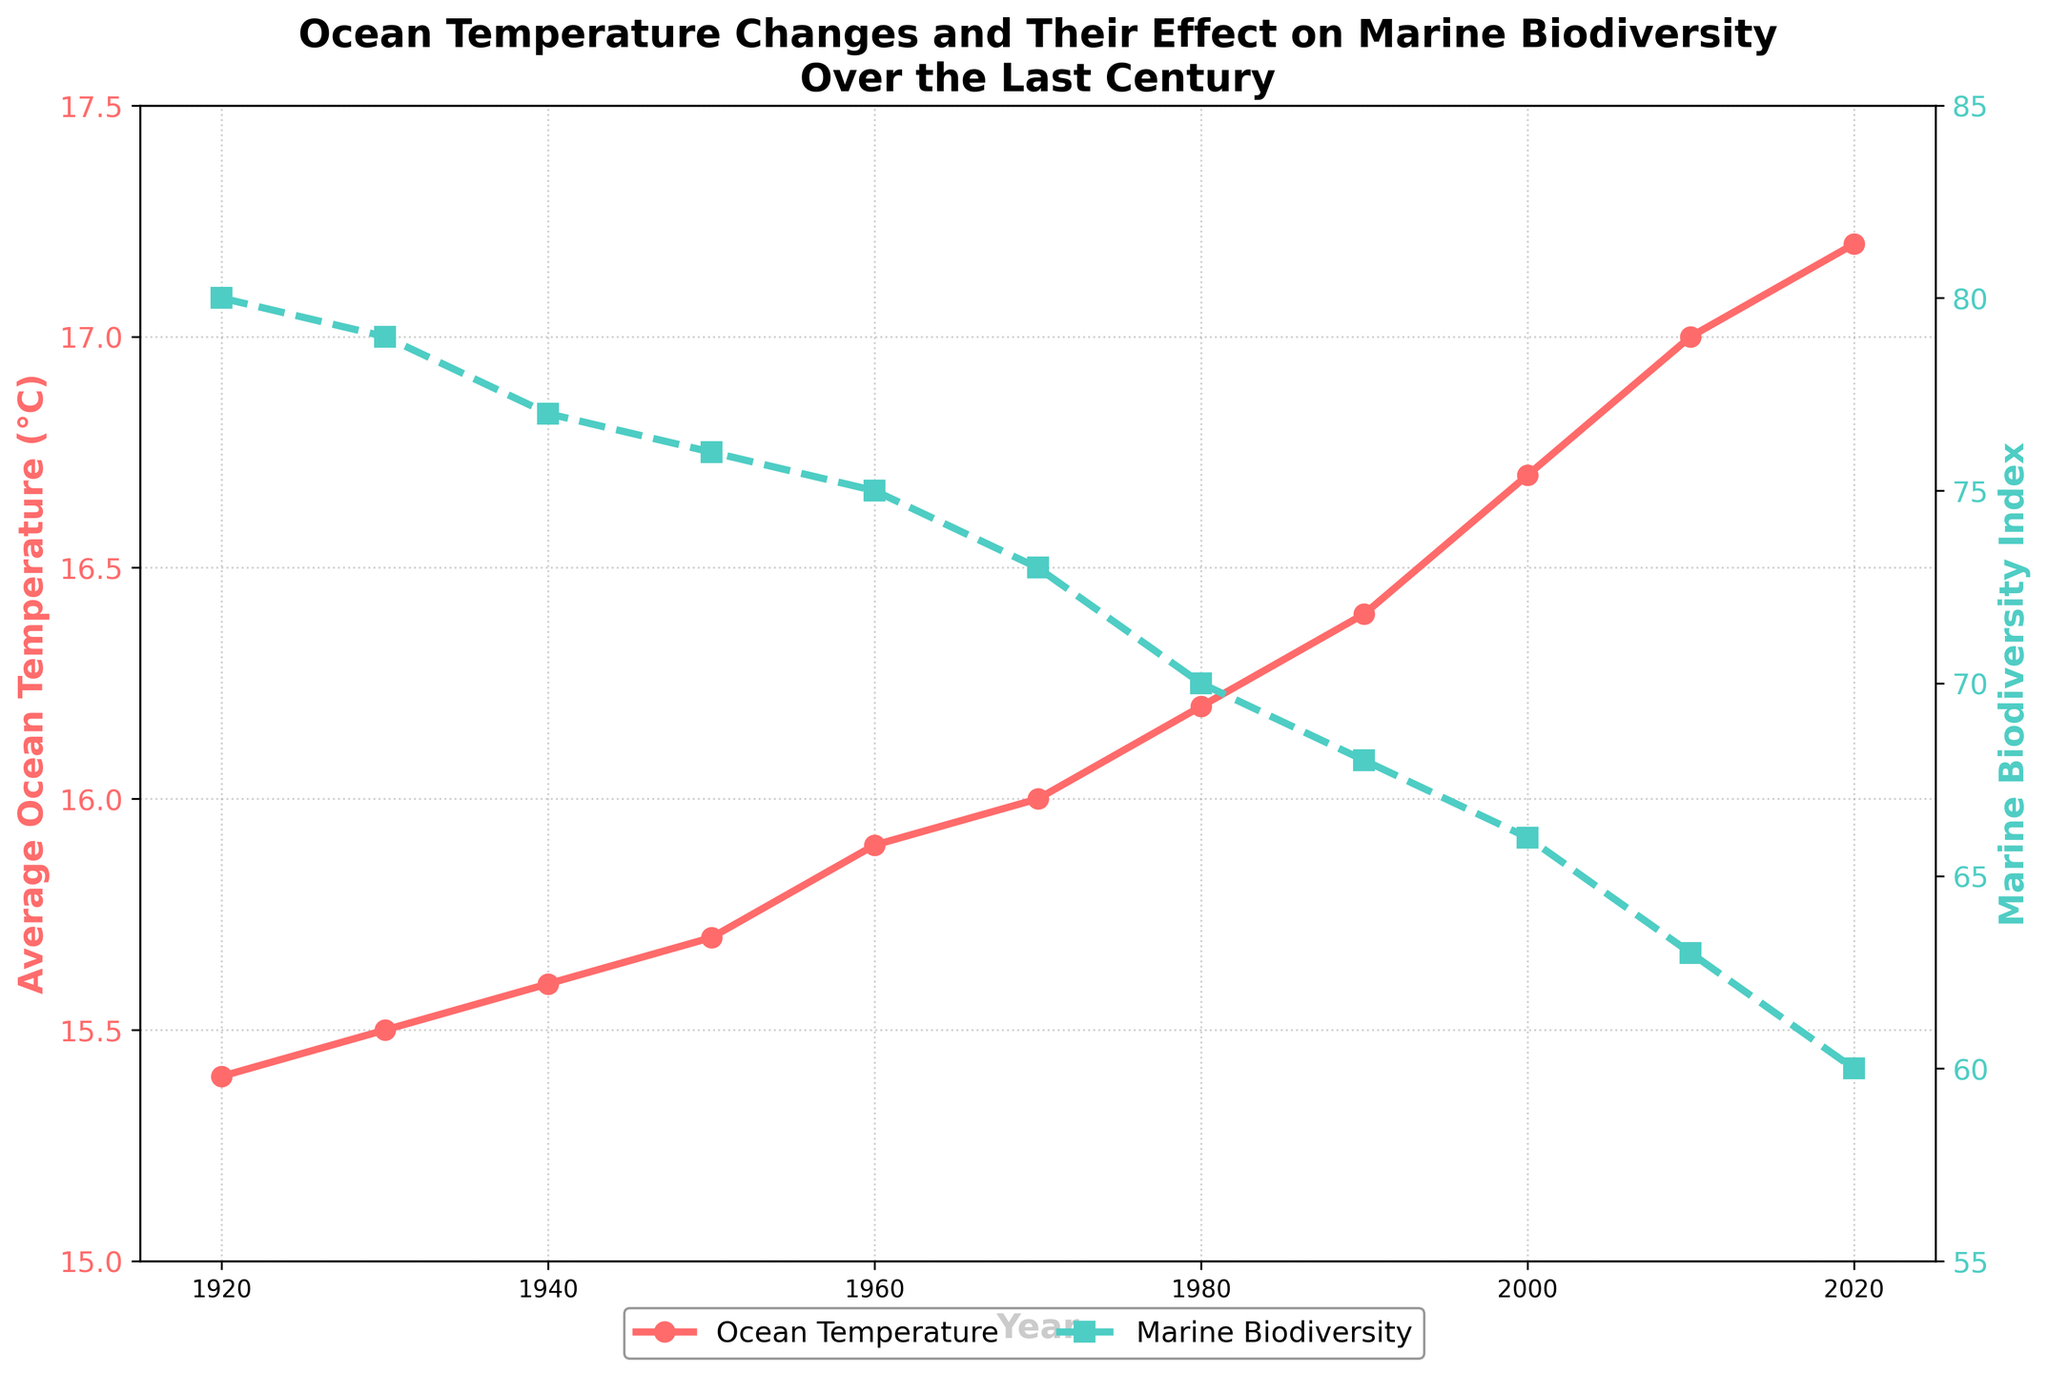What is the title of the plot? The title of the plot is located at the top and reads "Ocean Temperature Changes and Their Effect on Marine Biodiversity Over the Last Century."
Answer: Ocean Temperature Changes and Their Effect on Marine Biodiversity Over the Last Century What is the range of years depicted in the plot? The x-axis of the plot is labeled "Year" and ranges from 1915 to 2025.
Answer: 1915 to 2025 What color represents the Average Ocean Temperature data? The line representing Average Ocean Temperature is colored red. This color matches the description for the Average Ocean Temperature axis.
Answer: Red How many data points are there for Marine Biodiversity Index? Each year provided in the dataset corresponds to a Marine Biodiversity Index value. Counting the years will give the number of data points: 1920, 1930, 1940, 1950, 1960, 1970, 1980, 1990, 2000, 2010, 2020.
Answer: 11 Between which years does the Marine Biodiversity Index decrease the most? By inspecting the plot, the largest drop can be identified visually or by checking the values. The most significant decrease occurs between 2010 (63) and 2020 (60).
Answer: 2010 and 2020 What was the Average Ocean Temperature in the year 1950? Locate the year 1950 on the x-axis and trace the corresponding data point for the Average Ocean Temperature on the red line. The value is 15.7°C.
Answer: 15.7°C By how much did the Average Ocean Temperature increase from 1920 to 2020? The temperature in 1920 was 15.4°C and in 2020 it was 17.2°C. The increase is calculated as 17.2 - 15.4.
Answer: 1.8°C Compare the Marine Biodiversity Index in 1940 and 2000. How much did it change? In 1940, the Marine Biodiversity Index was 77; in 2000, it was 66. The change can be calculated by 77 - 66.
Answer: 11 What trend do you observe in the Average Ocean Temperature over the century? The plot shows a continuous upward trend in the Average Ocean Temperature from 15.4°C in 1920 to 17.2°C in 2020.
Answer: Upward trend How are the changes in Ocean Temperature related to Marine Biodiversity Index over the century? Observing both lines: as the Average Ocean Temperature rises over the years, the Marine Biodiversity Index decreases. Higher temperatures correlate with a declining biodiversity index.
Answer: Higher temperature, lower biodiversity 